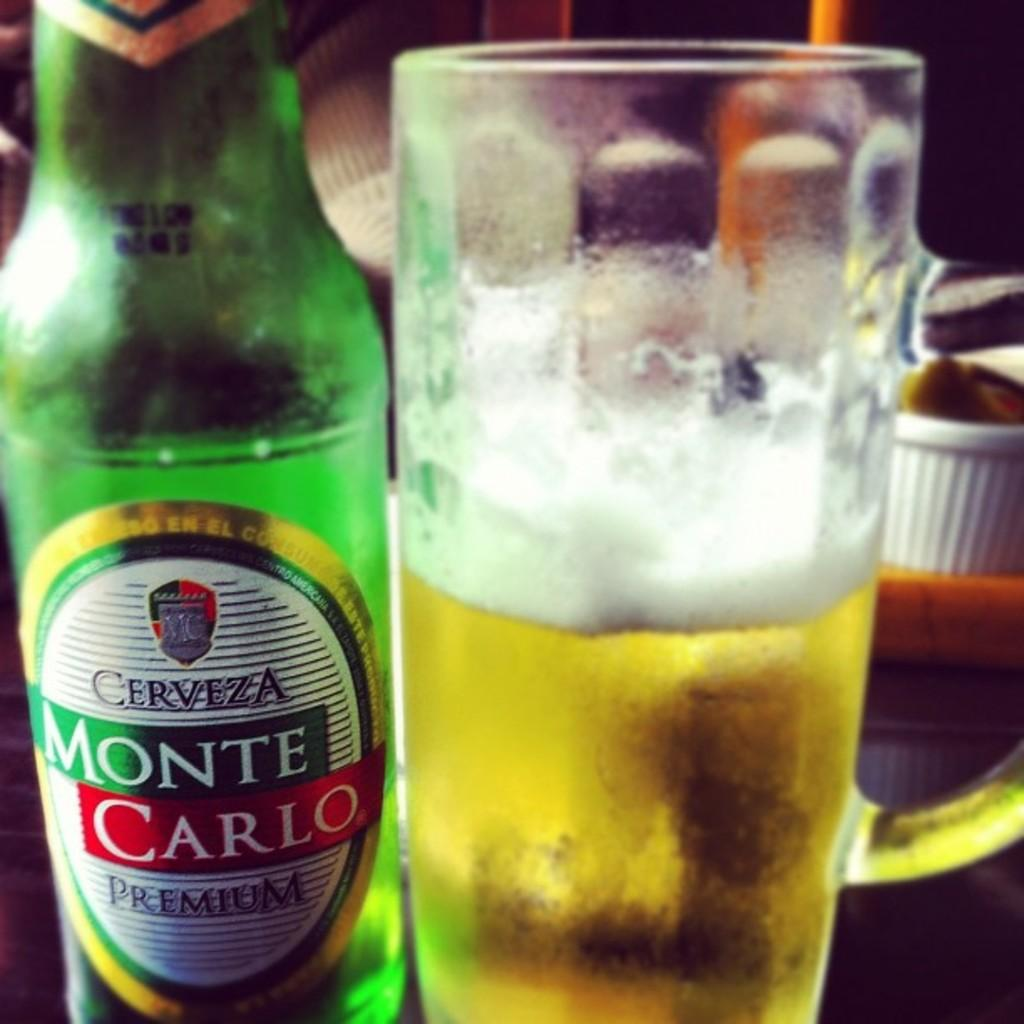<image>
Render a clear and concise summary of the photo. A green bottle of Cerveza Monte Carlo Premium beer. 